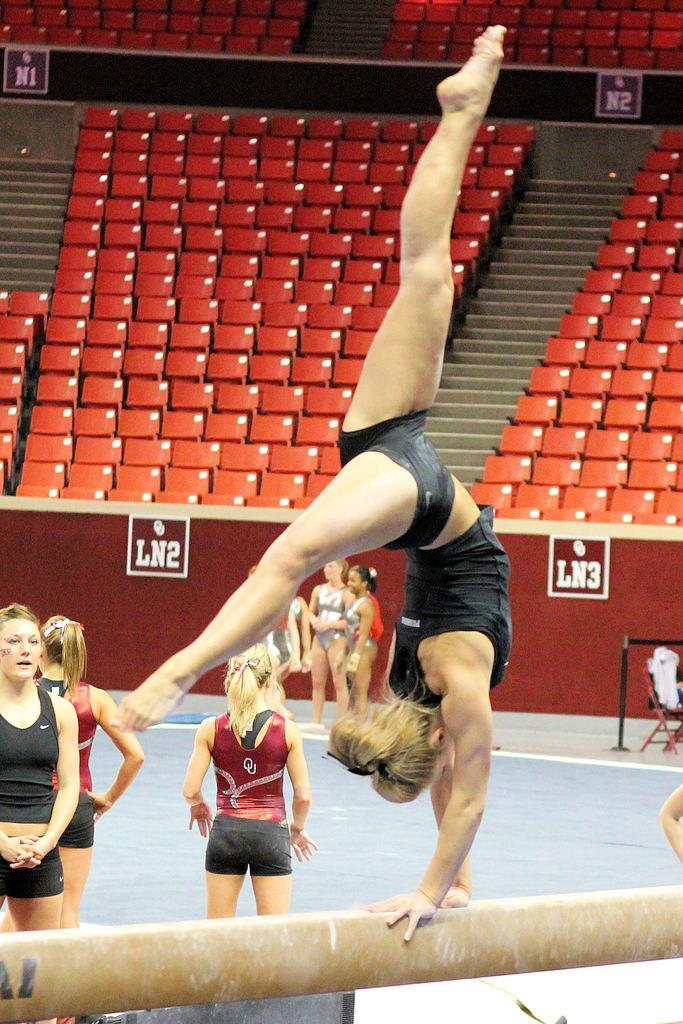Who or what can be seen in the image? There are people in the image. What color is the prominent wall in the image? There is a red wall in the image. What type of furniture is present in the image? There are chairs in the image. What objects are used for displaying information or messages in the image? There are boards in the image. What architectural feature is visible in the image? There are steps in the image. How many clams are sitting on the steps in the image? There are no clams present in the image; it features people, a red wall, chairs, boards, and steps. 